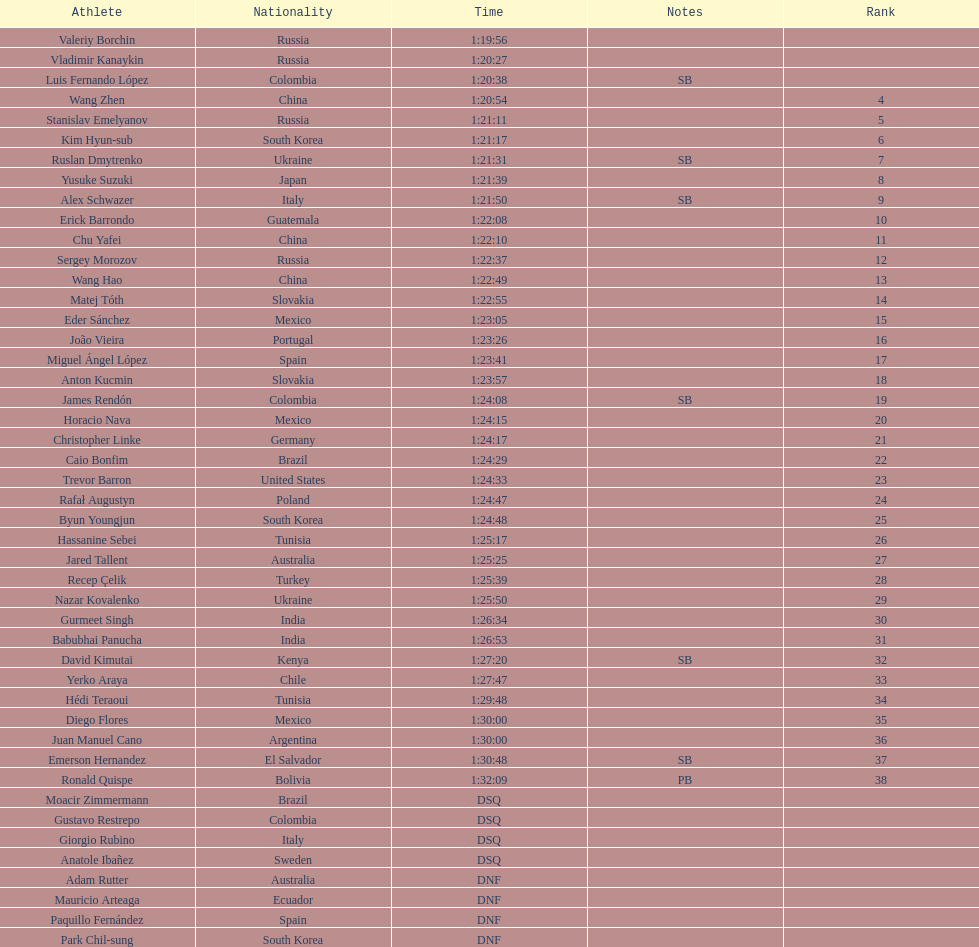Wang zhen and wang hao were both from which country? China. 